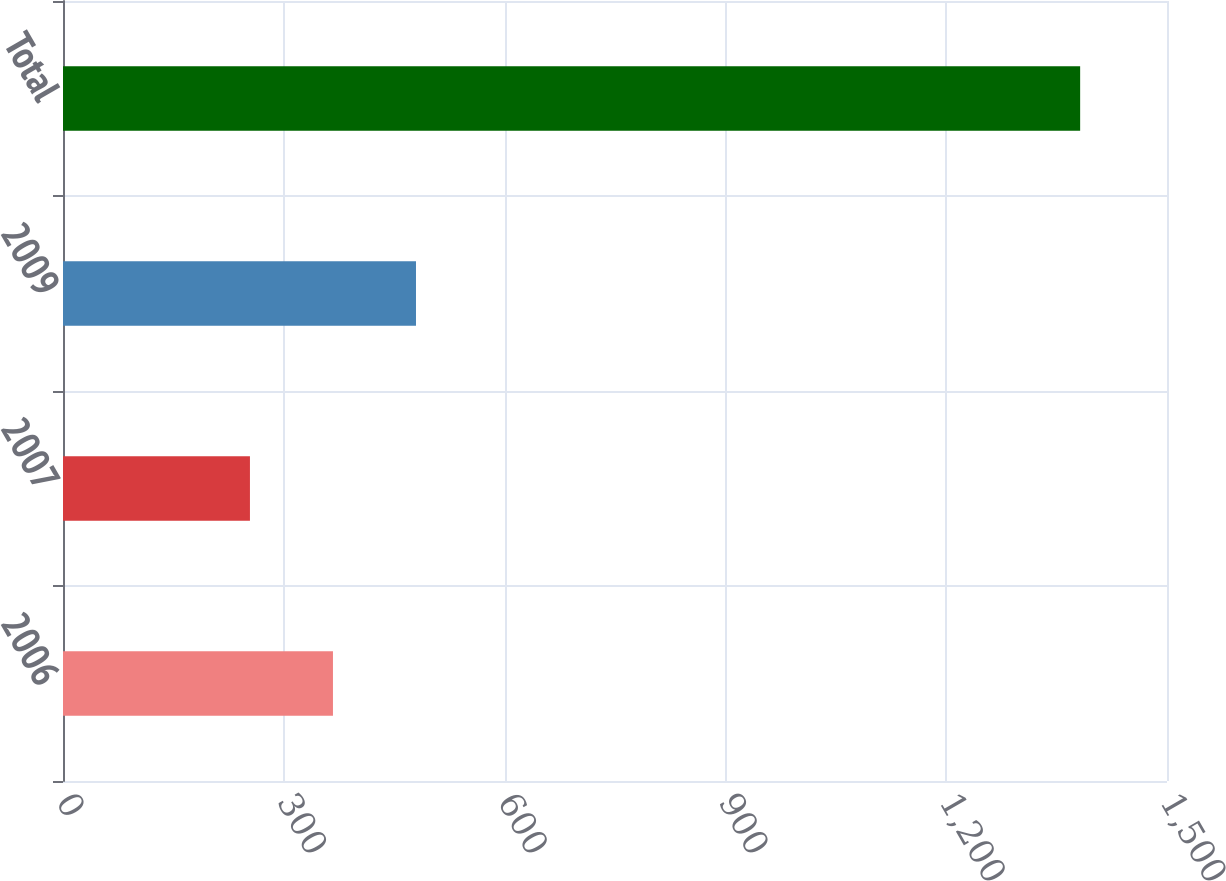<chart> <loc_0><loc_0><loc_500><loc_500><bar_chart><fcel>2006<fcel>2007<fcel>2009<fcel>Total<nl><fcel>366.8<fcel>254<fcel>479.6<fcel>1382<nl></chart> 